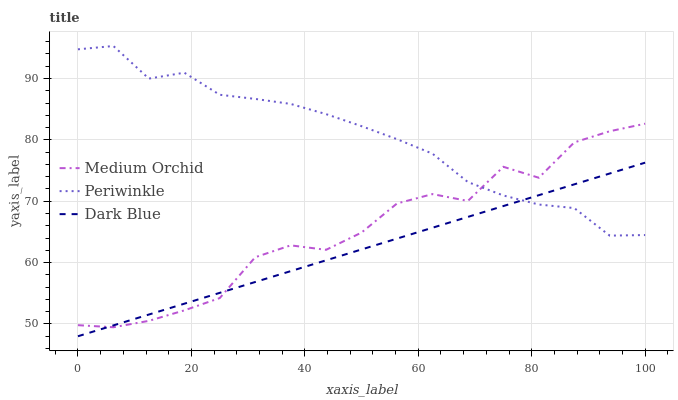Does Dark Blue have the minimum area under the curve?
Answer yes or no. Yes. Does Periwinkle have the maximum area under the curve?
Answer yes or no. Yes. Does Medium Orchid have the minimum area under the curve?
Answer yes or no. No. Does Medium Orchid have the maximum area under the curve?
Answer yes or no. No. Is Dark Blue the smoothest?
Answer yes or no. Yes. Is Medium Orchid the roughest?
Answer yes or no. Yes. Is Periwinkle the smoothest?
Answer yes or no. No. Is Periwinkle the roughest?
Answer yes or no. No. Does Dark Blue have the lowest value?
Answer yes or no. Yes. Does Medium Orchid have the lowest value?
Answer yes or no. No. Does Periwinkle have the highest value?
Answer yes or no. Yes. Does Medium Orchid have the highest value?
Answer yes or no. No. Does Dark Blue intersect Medium Orchid?
Answer yes or no. Yes. Is Dark Blue less than Medium Orchid?
Answer yes or no. No. Is Dark Blue greater than Medium Orchid?
Answer yes or no. No. 